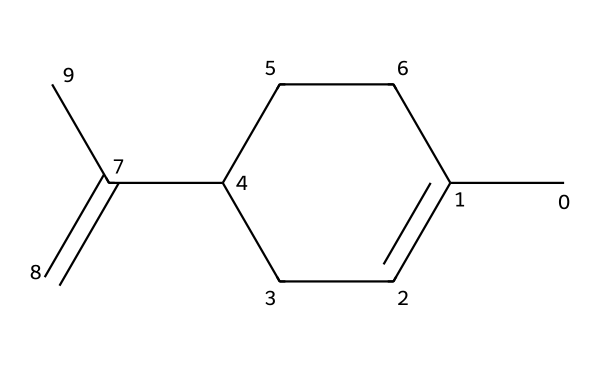What is the total number of carbon atoms in limonene? By examining the structure represented in the SMILES notation, you can count the carbon atoms. Each "C" in the SMILES indicates a carbon atom. Counting the occurrences, you find there are ten carbon atoms.
Answer: ten How many rings does limonene contain? Limonene is a cyclic compound, which means it contains at least one ring in its structure. The "C1=CCC(...)" notation indicates the presence of one ring. Thus, it contains one ring.
Answer: one What functional group is present in limonene? The structure of limonene shows a double bond in the cyclic part, which indicates the presence of an alkene functional group. This structural feature is what categorizes it as a cyclic terpene.
Answer: alkene Is limonene saturated or unsaturated? Limonene has a double bond in its structure, indicated by the "=C" part of the SMILES representation. A compound with a double bond is classified as unsaturated.
Answer: unsaturated How many hydrogen atoms are in limonene? To find the number of hydrogen atoms, you can use the general formula for alicyclic hydrocarbons. For limonene, derived from the carbon count of 10 and the presence of one double bond, the formula supports the total of 16 hydrogens.
Answer: sixteen What type of cyclic compound is limonene? Limonene is categorized as a cyclic terpene. Terpenes are compounds formed by joining isoprene units, and limonene specifically is a cyclic compound due to its ring structure and terpene classification.
Answer: cyclic terpene 